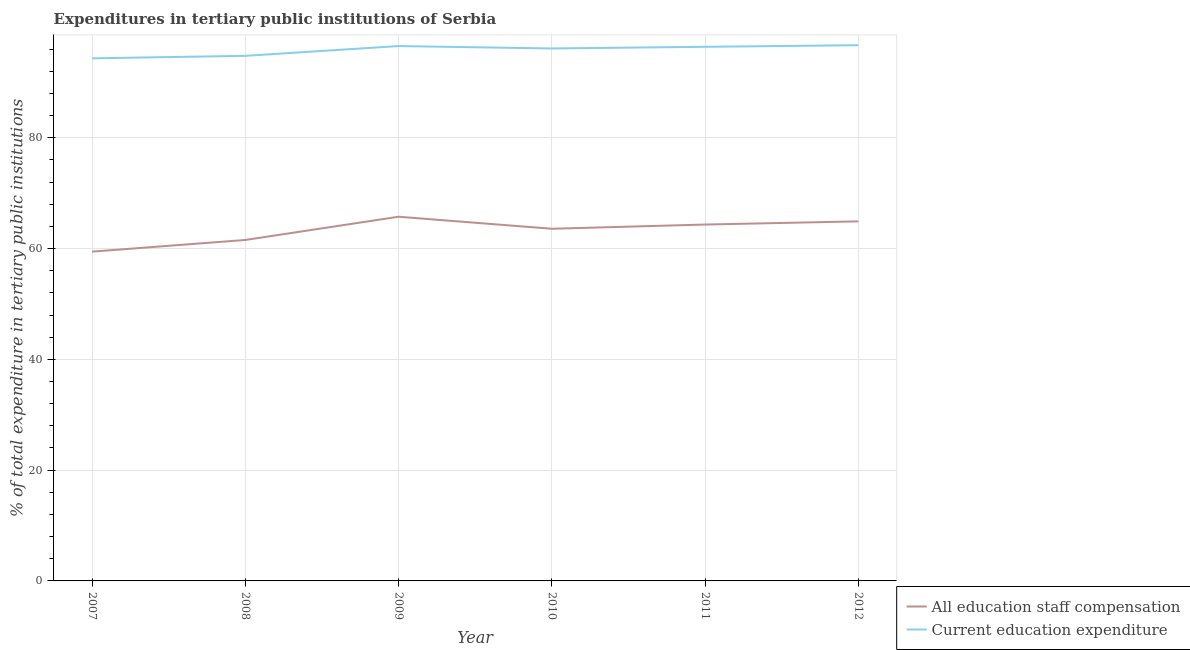How many different coloured lines are there?
Ensure brevity in your answer.  2. Is the number of lines equal to the number of legend labels?
Offer a terse response. Yes. What is the expenditure in education in 2008?
Keep it short and to the point. 94.79. Across all years, what is the maximum expenditure in education?
Make the answer very short. 96.71. Across all years, what is the minimum expenditure in staff compensation?
Keep it short and to the point. 59.44. In which year was the expenditure in education maximum?
Your response must be concise. 2012. In which year was the expenditure in staff compensation minimum?
Make the answer very short. 2007. What is the total expenditure in education in the graph?
Your answer should be very brief. 574.92. What is the difference between the expenditure in staff compensation in 2009 and that in 2011?
Give a very brief answer. 1.41. What is the difference between the expenditure in education in 2010 and the expenditure in staff compensation in 2011?
Make the answer very short. 31.78. What is the average expenditure in staff compensation per year?
Your answer should be compact. 63.26. In the year 2012, what is the difference between the expenditure in staff compensation and expenditure in education?
Give a very brief answer. -31.8. In how many years, is the expenditure in staff compensation greater than 28 %?
Make the answer very short. 6. What is the ratio of the expenditure in staff compensation in 2007 to that in 2011?
Offer a terse response. 0.92. Is the difference between the expenditure in education in 2010 and 2011 greater than the difference between the expenditure in staff compensation in 2010 and 2011?
Provide a short and direct response. Yes. What is the difference between the highest and the second highest expenditure in staff compensation?
Keep it short and to the point. 0.83. What is the difference between the highest and the lowest expenditure in staff compensation?
Offer a very short reply. 6.3. In how many years, is the expenditure in staff compensation greater than the average expenditure in staff compensation taken over all years?
Keep it short and to the point. 4. What is the difference between two consecutive major ticks on the Y-axis?
Keep it short and to the point. 20. Are the values on the major ticks of Y-axis written in scientific E-notation?
Offer a terse response. No. Where does the legend appear in the graph?
Offer a very short reply. Bottom right. How many legend labels are there?
Offer a very short reply. 2. What is the title of the graph?
Provide a short and direct response. Expenditures in tertiary public institutions of Serbia. What is the label or title of the X-axis?
Your response must be concise. Year. What is the label or title of the Y-axis?
Make the answer very short. % of total expenditure in tertiary public institutions. What is the % of total expenditure in tertiary public institutions of All education staff compensation in 2007?
Offer a terse response. 59.44. What is the % of total expenditure in tertiary public institutions in Current education expenditure in 2007?
Your answer should be very brief. 94.34. What is the % of total expenditure in tertiary public institutions of All education staff compensation in 2008?
Your response must be concise. 61.55. What is the % of total expenditure in tertiary public institutions in Current education expenditure in 2008?
Your response must be concise. 94.79. What is the % of total expenditure in tertiary public institutions in All education staff compensation in 2009?
Your answer should be very brief. 65.74. What is the % of total expenditure in tertiary public institutions in Current education expenditure in 2009?
Your answer should be very brief. 96.55. What is the % of total expenditure in tertiary public institutions of All education staff compensation in 2010?
Ensure brevity in your answer.  63.57. What is the % of total expenditure in tertiary public institutions of Current education expenditure in 2010?
Offer a very short reply. 96.12. What is the % of total expenditure in tertiary public institutions in All education staff compensation in 2011?
Provide a short and direct response. 64.33. What is the % of total expenditure in tertiary public institutions of Current education expenditure in 2011?
Offer a terse response. 96.42. What is the % of total expenditure in tertiary public institutions in All education staff compensation in 2012?
Provide a succinct answer. 64.91. What is the % of total expenditure in tertiary public institutions of Current education expenditure in 2012?
Your answer should be very brief. 96.71. Across all years, what is the maximum % of total expenditure in tertiary public institutions of All education staff compensation?
Your answer should be very brief. 65.74. Across all years, what is the maximum % of total expenditure in tertiary public institutions of Current education expenditure?
Keep it short and to the point. 96.71. Across all years, what is the minimum % of total expenditure in tertiary public institutions in All education staff compensation?
Provide a succinct answer. 59.44. Across all years, what is the minimum % of total expenditure in tertiary public institutions of Current education expenditure?
Your response must be concise. 94.34. What is the total % of total expenditure in tertiary public institutions in All education staff compensation in the graph?
Give a very brief answer. 379.54. What is the total % of total expenditure in tertiary public institutions of Current education expenditure in the graph?
Give a very brief answer. 574.92. What is the difference between the % of total expenditure in tertiary public institutions in All education staff compensation in 2007 and that in 2008?
Offer a terse response. -2.11. What is the difference between the % of total expenditure in tertiary public institutions of Current education expenditure in 2007 and that in 2008?
Offer a very short reply. -0.45. What is the difference between the % of total expenditure in tertiary public institutions in All education staff compensation in 2007 and that in 2009?
Provide a succinct answer. -6.3. What is the difference between the % of total expenditure in tertiary public institutions in Current education expenditure in 2007 and that in 2009?
Provide a succinct answer. -2.21. What is the difference between the % of total expenditure in tertiary public institutions of All education staff compensation in 2007 and that in 2010?
Give a very brief answer. -4.13. What is the difference between the % of total expenditure in tertiary public institutions in Current education expenditure in 2007 and that in 2010?
Give a very brief answer. -1.77. What is the difference between the % of total expenditure in tertiary public institutions in All education staff compensation in 2007 and that in 2011?
Keep it short and to the point. -4.89. What is the difference between the % of total expenditure in tertiary public institutions in Current education expenditure in 2007 and that in 2011?
Ensure brevity in your answer.  -2.07. What is the difference between the % of total expenditure in tertiary public institutions of All education staff compensation in 2007 and that in 2012?
Your answer should be compact. -5.47. What is the difference between the % of total expenditure in tertiary public institutions of Current education expenditure in 2007 and that in 2012?
Offer a terse response. -2.37. What is the difference between the % of total expenditure in tertiary public institutions of All education staff compensation in 2008 and that in 2009?
Keep it short and to the point. -4.19. What is the difference between the % of total expenditure in tertiary public institutions of Current education expenditure in 2008 and that in 2009?
Your answer should be compact. -1.77. What is the difference between the % of total expenditure in tertiary public institutions in All education staff compensation in 2008 and that in 2010?
Offer a terse response. -2.03. What is the difference between the % of total expenditure in tertiary public institutions of Current education expenditure in 2008 and that in 2010?
Make the answer very short. -1.33. What is the difference between the % of total expenditure in tertiary public institutions of All education staff compensation in 2008 and that in 2011?
Your answer should be very brief. -2.79. What is the difference between the % of total expenditure in tertiary public institutions of Current education expenditure in 2008 and that in 2011?
Your answer should be compact. -1.63. What is the difference between the % of total expenditure in tertiary public institutions in All education staff compensation in 2008 and that in 2012?
Keep it short and to the point. -3.36. What is the difference between the % of total expenditure in tertiary public institutions of Current education expenditure in 2008 and that in 2012?
Provide a short and direct response. -1.92. What is the difference between the % of total expenditure in tertiary public institutions of All education staff compensation in 2009 and that in 2010?
Ensure brevity in your answer.  2.17. What is the difference between the % of total expenditure in tertiary public institutions in Current education expenditure in 2009 and that in 2010?
Make the answer very short. 0.44. What is the difference between the % of total expenditure in tertiary public institutions in All education staff compensation in 2009 and that in 2011?
Keep it short and to the point. 1.41. What is the difference between the % of total expenditure in tertiary public institutions in Current education expenditure in 2009 and that in 2011?
Provide a succinct answer. 0.14. What is the difference between the % of total expenditure in tertiary public institutions in All education staff compensation in 2009 and that in 2012?
Give a very brief answer. 0.83. What is the difference between the % of total expenditure in tertiary public institutions of Current education expenditure in 2009 and that in 2012?
Provide a short and direct response. -0.16. What is the difference between the % of total expenditure in tertiary public institutions in All education staff compensation in 2010 and that in 2011?
Your answer should be very brief. -0.76. What is the difference between the % of total expenditure in tertiary public institutions in Current education expenditure in 2010 and that in 2011?
Ensure brevity in your answer.  -0.3. What is the difference between the % of total expenditure in tertiary public institutions of All education staff compensation in 2010 and that in 2012?
Your answer should be very brief. -1.33. What is the difference between the % of total expenditure in tertiary public institutions in Current education expenditure in 2010 and that in 2012?
Your response must be concise. -0.59. What is the difference between the % of total expenditure in tertiary public institutions of All education staff compensation in 2011 and that in 2012?
Provide a short and direct response. -0.57. What is the difference between the % of total expenditure in tertiary public institutions in Current education expenditure in 2011 and that in 2012?
Provide a succinct answer. -0.29. What is the difference between the % of total expenditure in tertiary public institutions of All education staff compensation in 2007 and the % of total expenditure in tertiary public institutions of Current education expenditure in 2008?
Provide a short and direct response. -35.35. What is the difference between the % of total expenditure in tertiary public institutions of All education staff compensation in 2007 and the % of total expenditure in tertiary public institutions of Current education expenditure in 2009?
Offer a very short reply. -37.11. What is the difference between the % of total expenditure in tertiary public institutions of All education staff compensation in 2007 and the % of total expenditure in tertiary public institutions of Current education expenditure in 2010?
Keep it short and to the point. -36.68. What is the difference between the % of total expenditure in tertiary public institutions of All education staff compensation in 2007 and the % of total expenditure in tertiary public institutions of Current education expenditure in 2011?
Ensure brevity in your answer.  -36.97. What is the difference between the % of total expenditure in tertiary public institutions of All education staff compensation in 2007 and the % of total expenditure in tertiary public institutions of Current education expenditure in 2012?
Give a very brief answer. -37.27. What is the difference between the % of total expenditure in tertiary public institutions in All education staff compensation in 2008 and the % of total expenditure in tertiary public institutions in Current education expenditure in 2009?
Offer a very short reply. -35.01. What is the difference between the % of total expenditure in tertiary public institutions of All education staff compensation in 2008 and the % of total expenditure in tertiary public institutions of Current education expenditure in 2010?
Your response must be concise. -34.57. What is the difference between the % of total expenditure in tertiary public institutions of All education staff compensation in 2008 and the % of total expenditure in tertiary public institutions of Current education expenditure in 2011?
Your answer should be compact. -34.87. What is the difference between the % of total expenditure in tertiary public institutions of All education staff compensation in 2008 and the % of total expenditure in tertiary public institutions of Current education expenditure in 2012?
Offer a very short reply. -35.16. What is the difference between the % of total expenditure in tertiary public institutions of All education staff compensation in 2009 and the % of total expenditure in tertiary public institutions of Current education expenditure in 2010?
Provide a short and direct response. -30.37. What is the difference between the % of total expenditure in tertiary public institutions in All education staff compensation in 2009 and the % of total expenditure in tertiary public institutions in Current education expenditure in 2011?
Your answer should be very brief. -30.67. What is the difference between the % of total expenditure in tertiary public institutions of All education staff compensation in 2009 and the % of total expenditure in tertiary public institutions of Current education expenditure in 2012?
Give a very brief answer. -30.97. What is the difference between the % of total expenditure in tertiary public institutions in All education staff compensation in 2010 and the % of total expenditure in tertiary public institutions in Current education expenditure in 2011?
Make the answer very short. -32.84. What is the difference between the % of total expenditure in tertiary public institutions in All education staff compensation in 2010 and the % of total expenditure in tertiary public institutions in Current education expenditure in 2012?
Ensure brevity in your answer.  -33.13. What is the difference between the % of total expenditure in tertiary public institutions in All education staff compensation in 2011 and the % of total expenditure in tertiary public institutions in Current education expenditure in 2012?
Offer a very short reply. -32.38. What is the average % of total expenditure in tertiary public institutions in All education staff compensation per year?
Your answer should be very brief. 63.26. What is the average % of total expenditure in tertiary public institutions of Current education expenditure per year?
Your answer should be compact. 95.82. In the year 2007, what is the difference between the % of total expenditure in tertiary public institutions in All education staff compensation and % of total expenditure in tertiary public institutions in Current education expenditure?
Give a very brief answer. -34.9. In the year 2008, what is the difference between the % of total expenditure in tertiary public institutions of All education staff compensation and % of total expenditure in tertiary public institutions of Current education expenditure?
Your response must be concise. -33.24. In the year 2009, what is the difference between the % of total expenditure in tertiary public institutions in All education staff compensation and % of total expenditure in tertiary public institutions in Current education expenditure?
Your response must be concise. -30.81. In the year 2010, what is the difference between the % of total expenditure in tertiary public institutions in All education staff compensation and % of total expenditure in tertiary public institutions in Current education expenditure?
Offer a terse response. -32.54. In the year 2011, what is the difference between the % of total expenditure in tertiary public institutions of All education staff compensation and % of total expenditure in tertiary public institutions of Current education expenditure?
Your answer should be very brief. -32.08. In the year 2012, what is the difference between the % of total expenditure in tertiary public institutions in All education staff compensation and % of total expenditure in tertiary public institutions in Current education expenditure?
Your answer should be very brief. -31.8. What is the ratio of the % of total expenditure in tertiary public institutions of All education staff compensation in 2007 to that in 2008?
Keep it short and to the point. 0.97. What is the ratio of the % of total expenditure in tertiary public institutions in All education staff compensation in 2007 to that in 2009?
Provide a succinct answer. 0.9. What is the ratio of the % of total expenditure in tertiary public institutions of Current education expenditure in 2007 to that in 2009?
Keep it short and to the point. 0.98. What is the ratio of the % of total expenditure in tertiary public institutions in All education staff compensation in 2007 to that in 2010?
Your answer should be very brief. 0.94. What is the ratio of the % of total expenditure in tertiary public institutions of Current education expenditure in 2007 to that in 2010?
Your answer should be very brief. 0.98. What is the ratio of the % of total expenditure in tertiary public institutions of All education staff compensation in 2007 to that in 2011?
Your answer should be very brief. 0.92. What is the ratio of the % of total expenditure in tertiary public institutions of Current education expenditure in 2007 to that in 2011?
Your answer should be compact. 0.98. What is the ratio of the % of total expenditure in tertiary public institutions of All education staff compensation in 2007 to that in 2012?
Provide a short and direct response. 0.92. What is the ratio of the % of total expenditure in tertiary public institutions of Current education expenditure in 2007 to that in 2012?
Give a very brief answer. 0.98. What is the ratio of the % of total expenditure in tertiary public institutions in All education staff compensation in 2008 to that in 2009?
Your answer should be compact. 0.94. What is the ratio of the % of total expenditure in tertiary public institutions of Current education expenditure in 2008 to that in 2009?
Provide a succinct answer. 0.98. What is the ratio of the % of total expenditure in tertiary public institutions of All education staff compensation in 2008 to that in 2010?
Keep it short and to the point. 0.97. What is the ratio of the % of total expenditure in tertiary public institutions of Current education expenditure in 2008 to that in 2010?
Provide a succinct answer. 0.99. What is the ratio of the % of total expenditure in tertiary public institutions of All education staff compensation in 2008 to that in 2011?
Provide a short and direct response. 0.96. What is the ratio of the % of total expenditure in tertiary public institutions in Current education expenditure in 2008 to that in 2011?
Offer a terse response. 0.98. What is the ratio of the % of total expenditure in tertiary public institutions in All education staff compensation in 2008 to that in 2012?
Make the answer very short. 0.95. What is the ratio of the % of total expenditure in tertiary public institutions of Current education expenditure in 2008 to that in 2012?
Ensure brevity in your answer.  0.98. What is the ratio of the % of total expenditure in tertiary public institutions in All education staff compensation in 2009 to that in 2010?
Keep it short and to the point. 1.03. What is the ratio of the % of total expenditure in tertiary public institutions in Current education expenditure in 2009 to that in 2010?
Your answer should be very brief. 1. What is the ratio of the % of total expenditure in tertiary public institutions in All education staff compensation in 2009 to that in 2011?
Give a very brief answer. 1.02. What is the ratio of the % of total expenditure in tertiary public institutions of Current education expenditure in 2009 to that in 2011?
Make the answer very short. 1. What is the ratio of the % of total expenditure in tertiary public institutions of All education staff compensation in 2009 to that in 2012?
Keep it short and to the point. 1.01. What is the ratio of the % of total expenditure in tertiary public institutions in Current education expenditure in 2009 to that in 2012?
Offer a very short reply. 1. What is the ratio of the % of total expenditure in tertiary public institutions of All education staff compensation in 2010 to that in 2012?
Ensure brevity in your answer.  0.98. What is the difference between the highest and the second highest % of total expenditure in tertiary public institutions of All education staff compensation?
Offer a terse response. 0.83. What is the difference between the highest and the second highest % of total expenditure in tertiary public institutions in Current education expenditure?
Ensure brevity in your answer.  0.16. What is the difference between the highest and the lowest % of total expenditure in tertiary public institutions of All education staff compensation?
Provide a succinct answer. 6.3. What is the difference between the highest and the lowest % of total expenditure in tertiary public institutions of Current education expenditure?
Offer a terse response. 2.37. 